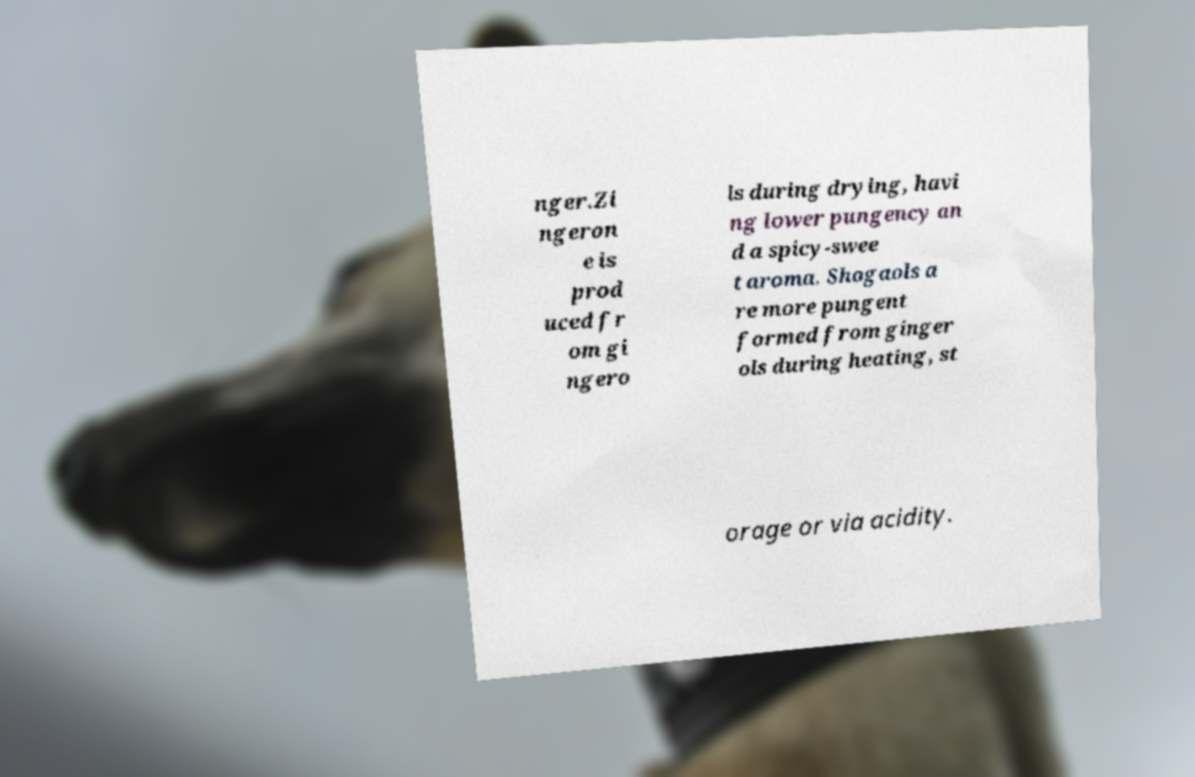Could you extract and type out the text from this image? nger.Zi ngeron e is prod uced fr om gi ngero ls during drying, havi ng lower pungency an d a spicy-swee t aroma. Shogaols a re more pungent formed from ginger ols during heating, st orage or via acidity. 